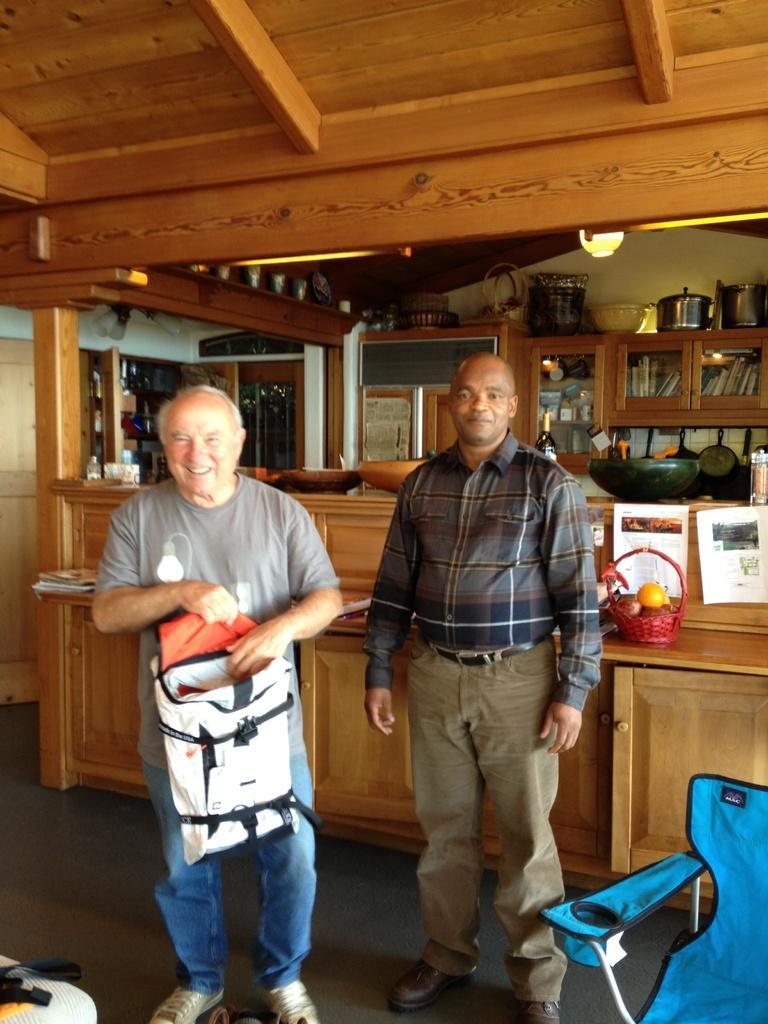Describe this image in one or two sentences. As we can see in the image there is chair, two people standing, table, rack filled with books, dishes, light and papers. On table there are books and fruits. The person standing on the left side is wearing grey color t shirt and holding bag. The person on the right side is wearing black color shirt. 